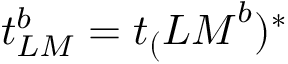<formula> <loc_0><loc_0><loc_500><loc_500>t _ { L M } ^ { b } = t _ { ( } { L M } ^ { b } ) ^ { * }</formula> 